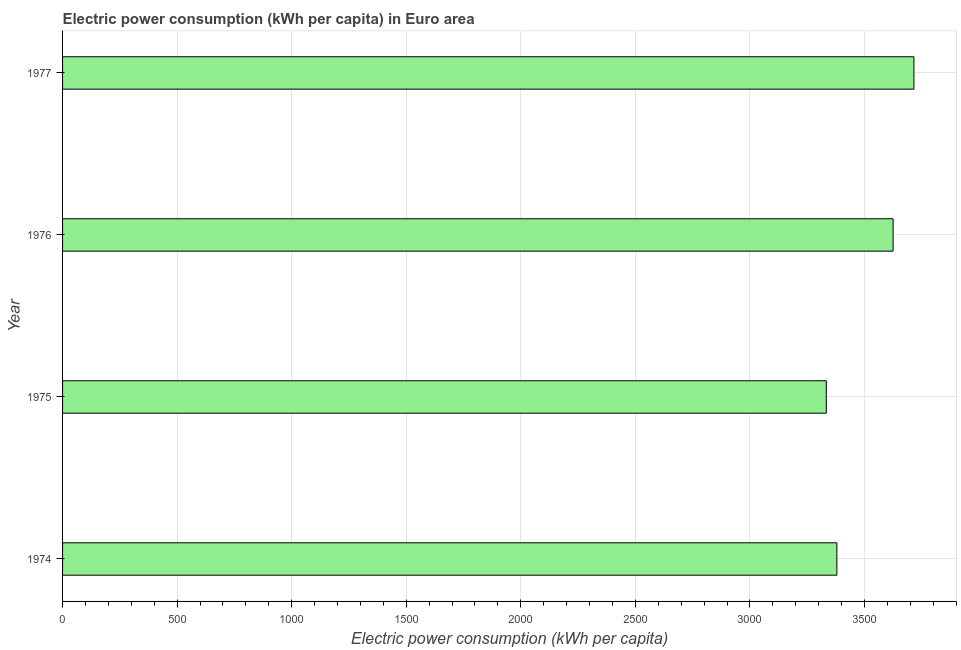Does the graph contain grids?
Provide a succinct answer. Yes. What is the title of the graph?
Your answer should be compact. Electric power consumption (kWh per capita) in Euro area. What is the label or title of the X-axis?
Give a very brief answer. Electric power consumption (kWh per capita). What is the electric power consumption in 1976?
Your answer should be very brief. 3624.8. Across all years, what is the maximum electric power consumption?
Provide a short and direct response. 3715.69. Across all years, what is the minimum electric power consumption?
Keep it short and to the point. 3333.22. In which year was the electric power consumption minimum?
Provide a succinct answer. 1975. What is the sum of the electric power consumption?
Offer a very short reply. 1.41e+04. What is the difference between the electric power consumption in 1974 and 1976?
Make the answer very short. -245.42. What is the average electric power consumption per year?
Your answer should be very brief. 3513.27. What is the median electric power consumption?
Offer a very short reply. 3502.09. In how many years, is the electric power consumption greater than 3200 kWh per capita?
Give a very brief answer. 4. Do a majority of the years between 1976 and 1975 (inclusive) have electric power consumption greater than 400 kWh per capita?
Keep it short and to the point. No. What is the ratio of the electric power consumption in 1974 to that in 1977?
Your answer should be very brief. 0.91. Is the electric power consumption in 1976 less than that in 1977?
Your response must be concise. Yes. What is the difference between the highest and the second highest electric power consumption?
Keep it short and to the point. 90.89. Is the sum of the electric power consumption in 1975 and 1977 greater than the maximum electric power consumption across all years?
Keep it short and to the point. Yes. What is the difference between the highest and the lowest electric power consumption?
Your response must be concise. 382.48. How many bars are there?
Ensure brevity in your answer.  4. What is the difference between two consecutive major ticks on the X-axis?
Ensure brevity in your answer.  500. Are the values on the major ticks of X-axis written in scientific E-notation?
Your answer should be very brief. No. What is the Electric power consumption (kWh per capita) in 1974?
Your answer should be very brief. 3379.38. What is the Electric power consumption (kWh per capita) in 1975?
Offer a terse response. 3333.22. What is the Electric power consumption (kWh per capita) of 1976?
Make the answer very short. 3624.8. What is the Electric power consumption (kWh per capita) of 1977?
Provide a short and direct response. 3715.69. What is the difference between the Electric power consumption (kWh per capita) in 1974 and 1975?
Offer a very short reply. 46.16. What is the difference between the Electric power consumption (kWh per capita) in 1974 and 1976?
Give a very brief answer. -245.42. What is the difference between the Electric power consumption (kWh per capita) in 1974 and 1977?
Keep it short and to the point. -336.32. What is the difference between the Electric power consumption (kWh per capita) in 1975 and 1976?
Provide a succinct answer. -291.58. What is the difference between the Electric power consumption (kWh per capita) in 1975 and 1977?
Make the answer very short. -382.48. What is the difference between the Electric power consumption (kWh per capita) in 1976 and 1977?
Provide a succinct answer. -90.89. What is the ratio of the Electric power consumption (kWh per capita) in 1974 to that in 1976?
Ensure brevity in your answer.  0.93. What is the ratio of the Electric power consumption (kWh per capita) in 1974 to that in 1977?
Keep it short and to the point. 0.91. What is the ratio of the Electric power consumption (kWh per capita) in 1975 to that in 1976?
Ensure brevity in your answer.  0.92. What is the ratio of the Electric power consumption (kWh per capita) in 1975 to that in 1977?
Your answer should be compact. 0.9. What is the ratio of the Electric power consumption (kWh per capita) in 1976 to that in 1977?
Give a very brief answer. 0.98. 